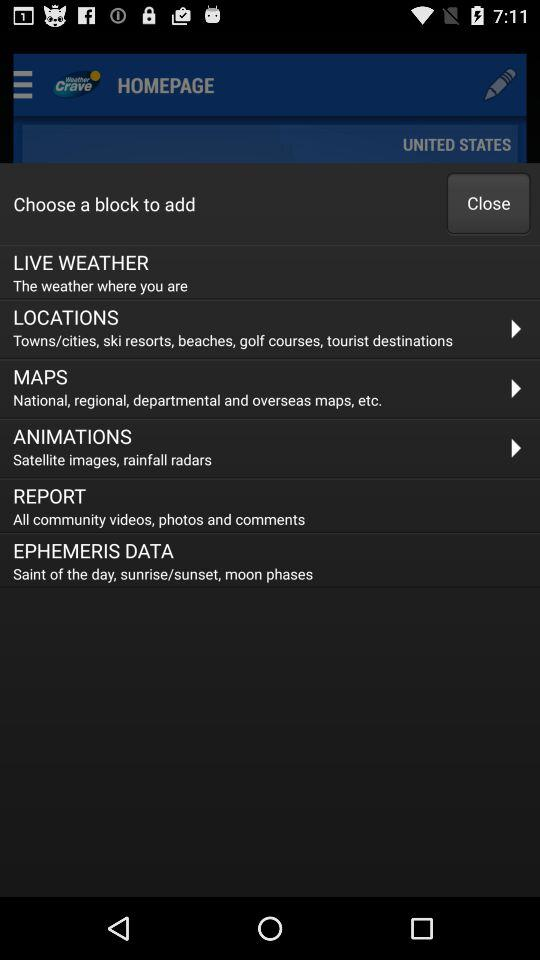How many videos are in "REPORT"?
When the provided information is insufficient, respond with <no answer>. <no answer> 